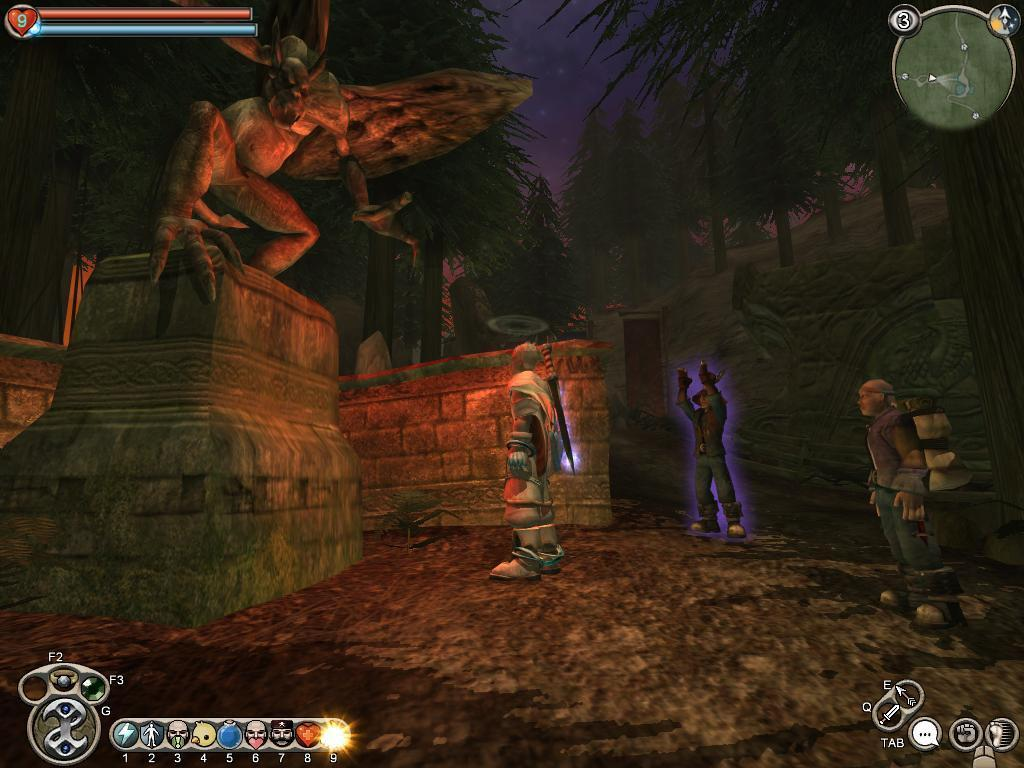What type of image is being described? The image is an animation. What can be seen on the left side of the image? There is a sculpture on a wall on the left side of the image. Are there any living beings present in the image? Yes, there are people present in the image. What additional design elements can be found in the image? There are icons in the corners of the image. What type of environment is depicted in the background of the image? There are trees visible in the background of the image. How many pies are being served on the sofa in the image? There is no sofa or pies present in the image. What fact is being presented in the image? The image is an animation, but there is no specific fact being presented in the image. 